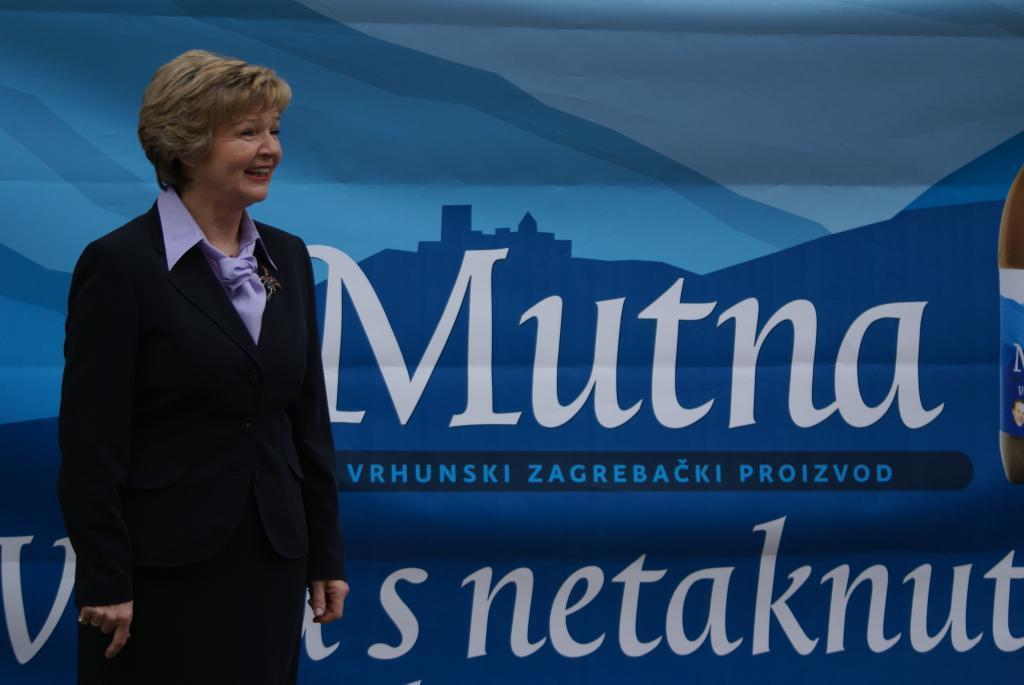Could you give a brief overview of what you see in this image? There is a lady who is standing on the left side of the image and there is a poster in the background area. 